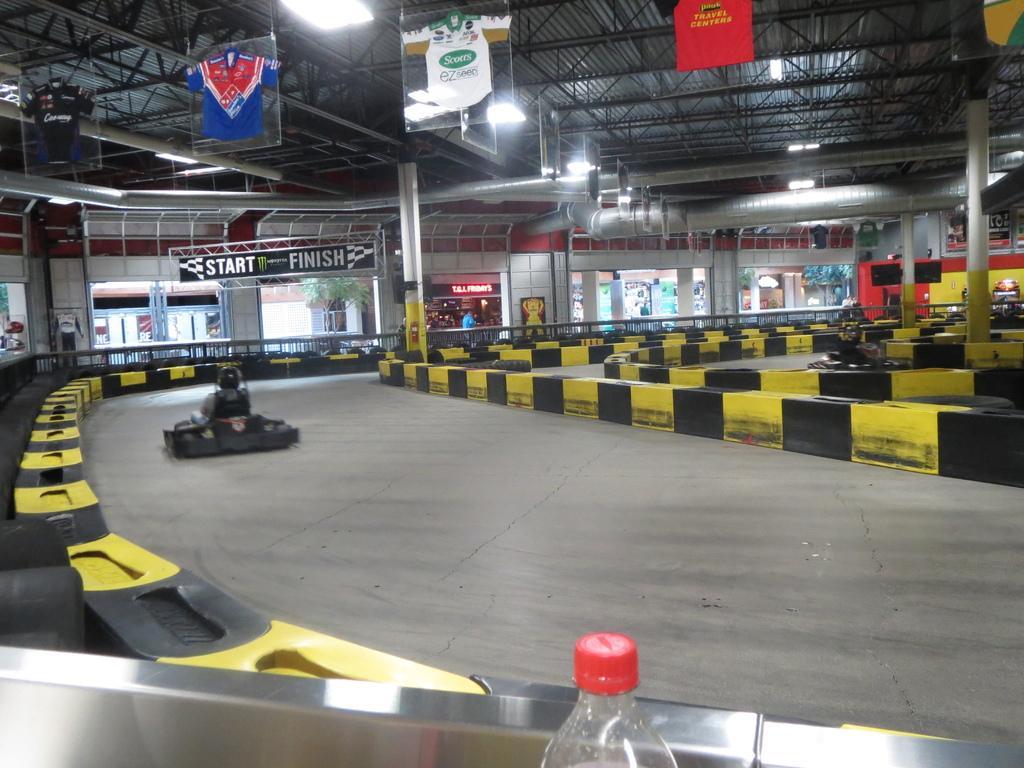Can you describe this image briefly? In this picture we can see a bottle and two persons on vehicles and in the background we can see pillars, plant, banners. 